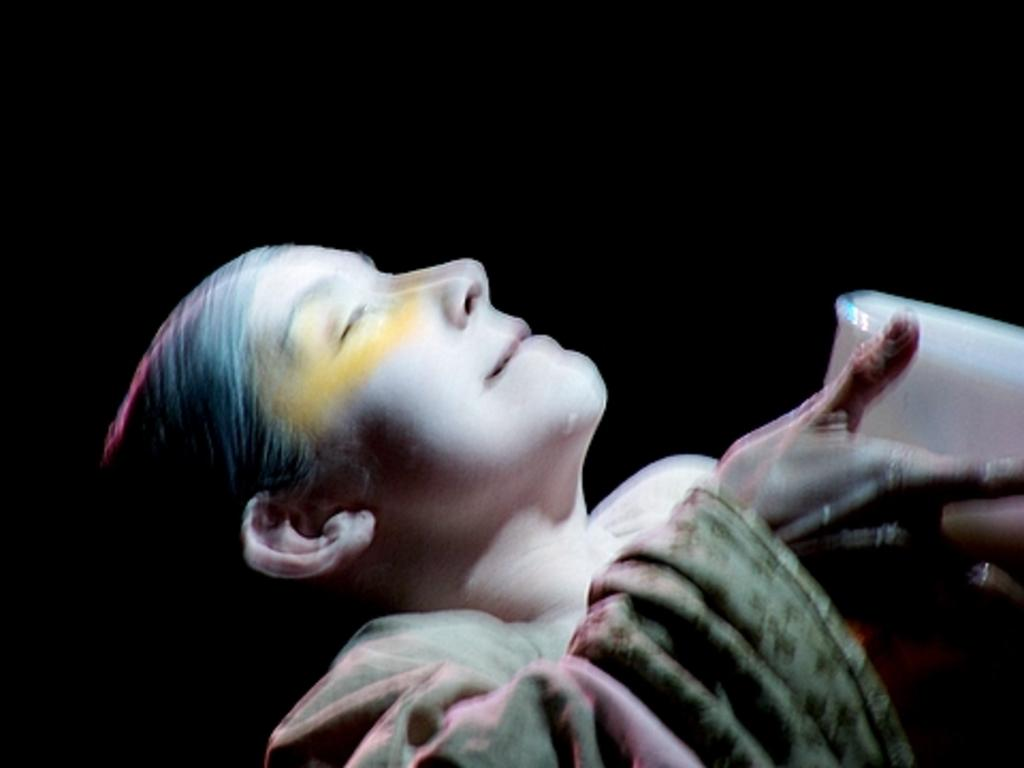What is present in the image? There is a person in the image. What is the person holding in her hands? The person is holding a box in her hands. What type of flowers can be seen growing out of the box in the image? There are no flowers present in the image, and the box is not shown to be growing anything. 